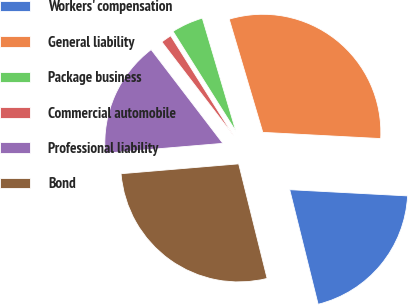Convert chart to OTSL. <chart><loc_0><loc_0><loc_500><loc_500><pie_chart><fcel>Workers' compensation<fcel>General liability<fcel>Package business<fcel>Commercial automobile<fcel>Professional liability<fcel>Bond<nl><fcel>20.29%<fcel>30.43%<fcel>4.35%<fcel>1.45%<fcel>15.94%<fcel>27.54%<nl></chart> 